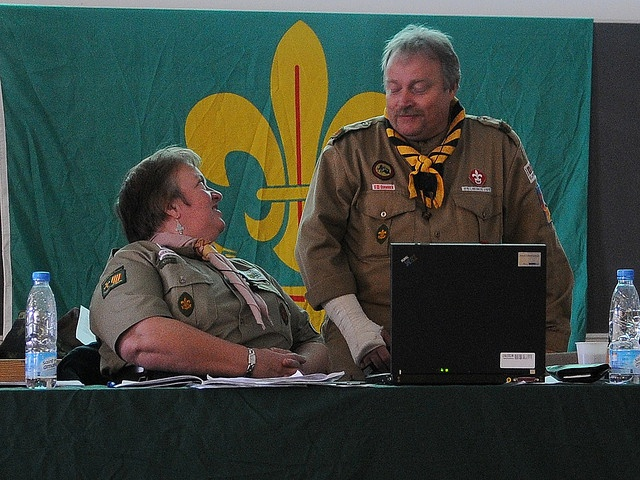Describe the objects in this image and their specific colors. I can see people in darkgray, black, maroon, and gray tones, people in darkgray, black, gray, brown, and maroon tones, laptop in darkgray, black, gray, and lightgray tones, tie in darkgray, black, red, and maroon tones, and bottle in darkgray and gray tones in this image. 